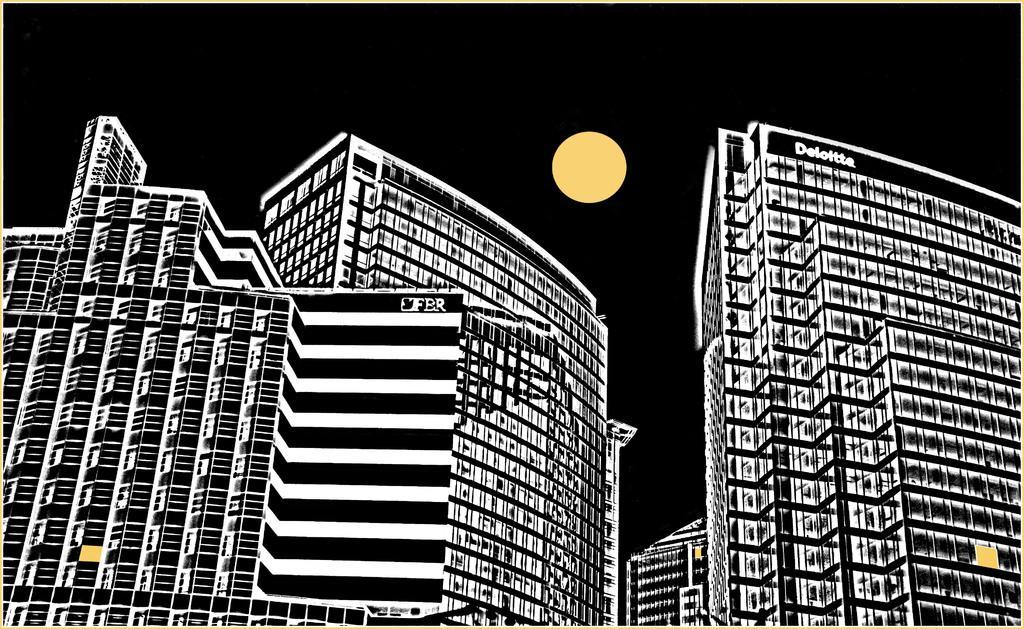Please provide a concise description of this image. In this picture, we can see an edited image of a few buildings with some text on it, and we can see the moon. 